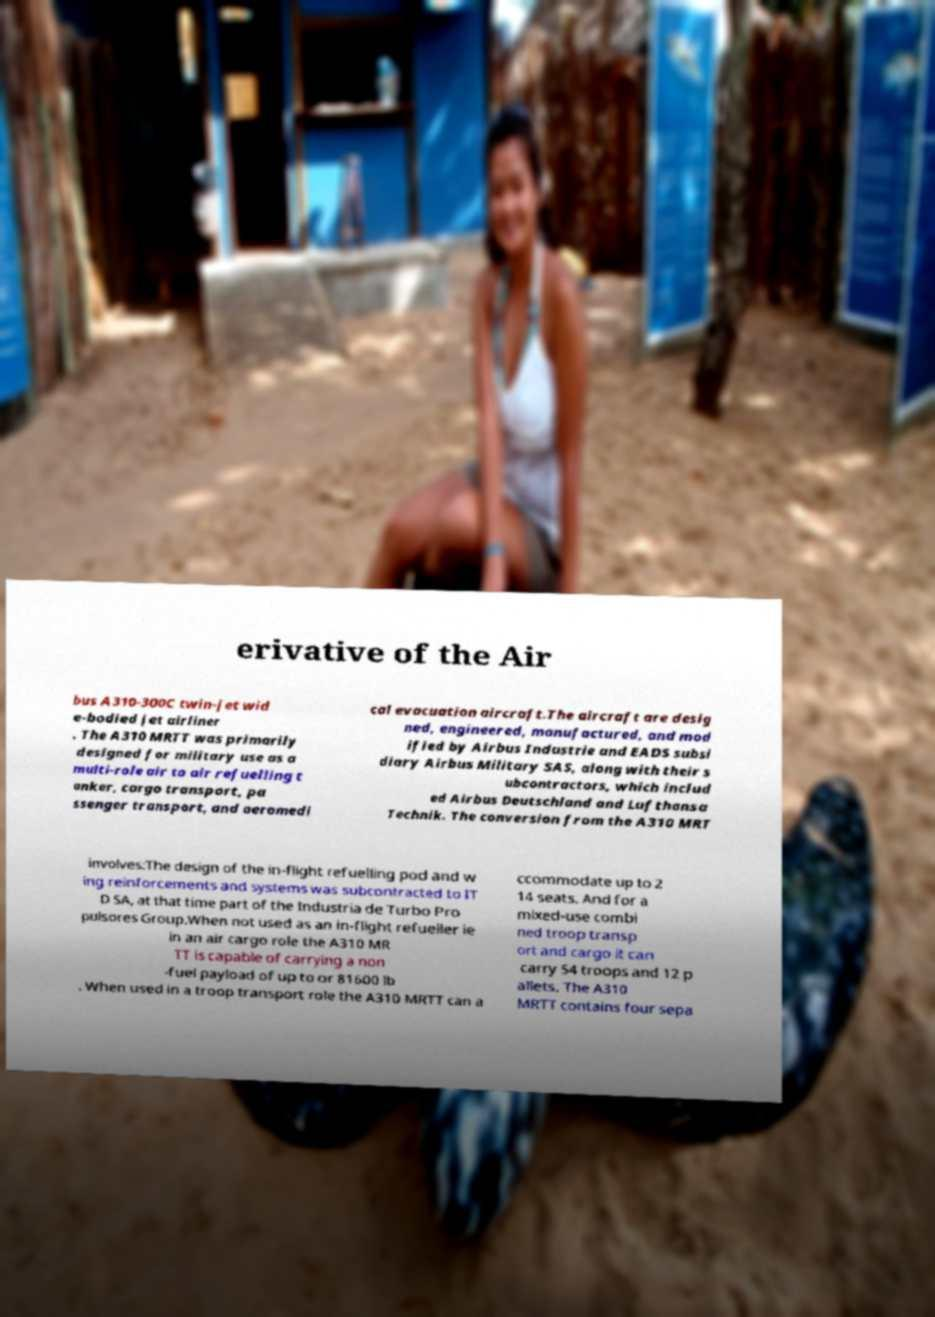For documentation purposes, I need the text within this image transcribed. Could you provide that? erivative of the Air bus A310-300C twin-jet wid e-bodied jet airliner . The A310 MRTT was primarily designed for military use as a multi-role air to air refuelling t anker, cargo transport, pa ssenger transport, and aeromedi cal evacuation aircraft.The aircraft are desig ned, engineered, manufactured, and mod ified by Airbus Industrie and EADS subsi diary Airbus Military SAS, along with their s ubcontractors, which includ ed Airbus Deutschland and Lufthansa Technik. The conversion from the A310 MRT involves:The design of the in-flight refuelling pod and w ing reinforcements and systems was subcontracted to IT D SA, at that time part of the Industria de Turbo Pro pulsores Group.When not used as an in-flight refueller ie in an air cargo role the A310 MR TT is capable of carrying a non -fuel payload of up to or 81600 lb . When used in a troop transport role the A310 MRTT can a ccommodate up to 2 14 seats. And for a mixed-use combi ned troop transp ort and cargo it can carry 54 troops and 12 p allets. The A310 MRTT contains four sepa 